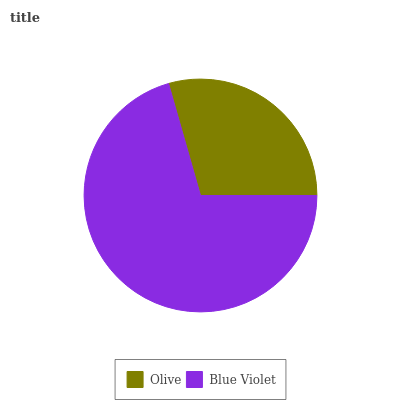Is Olive the minimum?
Answer yes or no. Yes. Is Blue Violet the maximum?
Answer yes or no. Yes. Is Blue Violet the minimum?
Answer yes or no. No. Is Blue Violet greater than Olive?
Answer yes or no. Yes. Is Olive less than Blue Violet?
Answer yes or no. Yes. Is Olive greater than Blue Violet?
Answer yes or no. No. Is Blue Violet less than Olive?
Answer yes or no. No. Is Blue Violet the high median?
Answer yes or no. Yes. Is Olive the low median?
Answer yes or no. Yes. Is Olive the high median?
Answer yes or no. No. Is Blue Violet the low median?
Answer yes or no. No. 